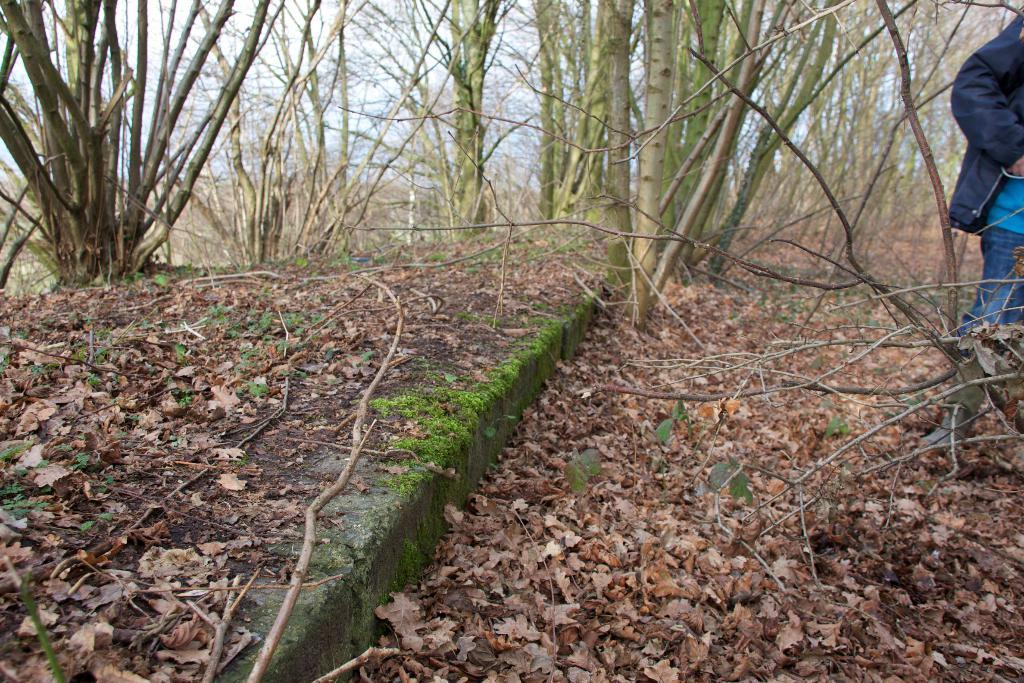What type of vegetation can be seen in the image? There are trees in the image. What is present on the ground beneath the trees? Dry leaves are present on the ground. Where is the person located in the image? The person is on the right side of the image. What can be seen in the sky in the image? The sky is visible in the image. What decision does the person make in the image? There is no indication of a decision being made in the image; it simply shows a person standing near trees with dry leaves on the ground. 